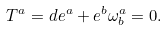Convert formula to latex. <formula><loc_0><loc_0><loc_500><loc_500>T ^ { a } = d e ^ { a } + e ^ { b } \omega ^ { a } _ { b } = 0 .</formula> 